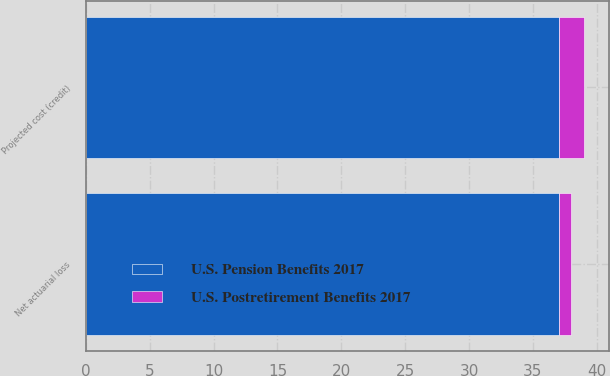<chart> <loc_0><loc_0><loc_500><loc_500><stacked_bar_chart><ecel><fcel>Net actuarial loss<fcel>Projected cost (credit)<nl><fcel>U.S. Pension Benefits 2017<fcel>37<fcel>37<nl><fcel>U.S. Postretirement Benefits 2017<fcel>1<fcel>2<nl></chart> 